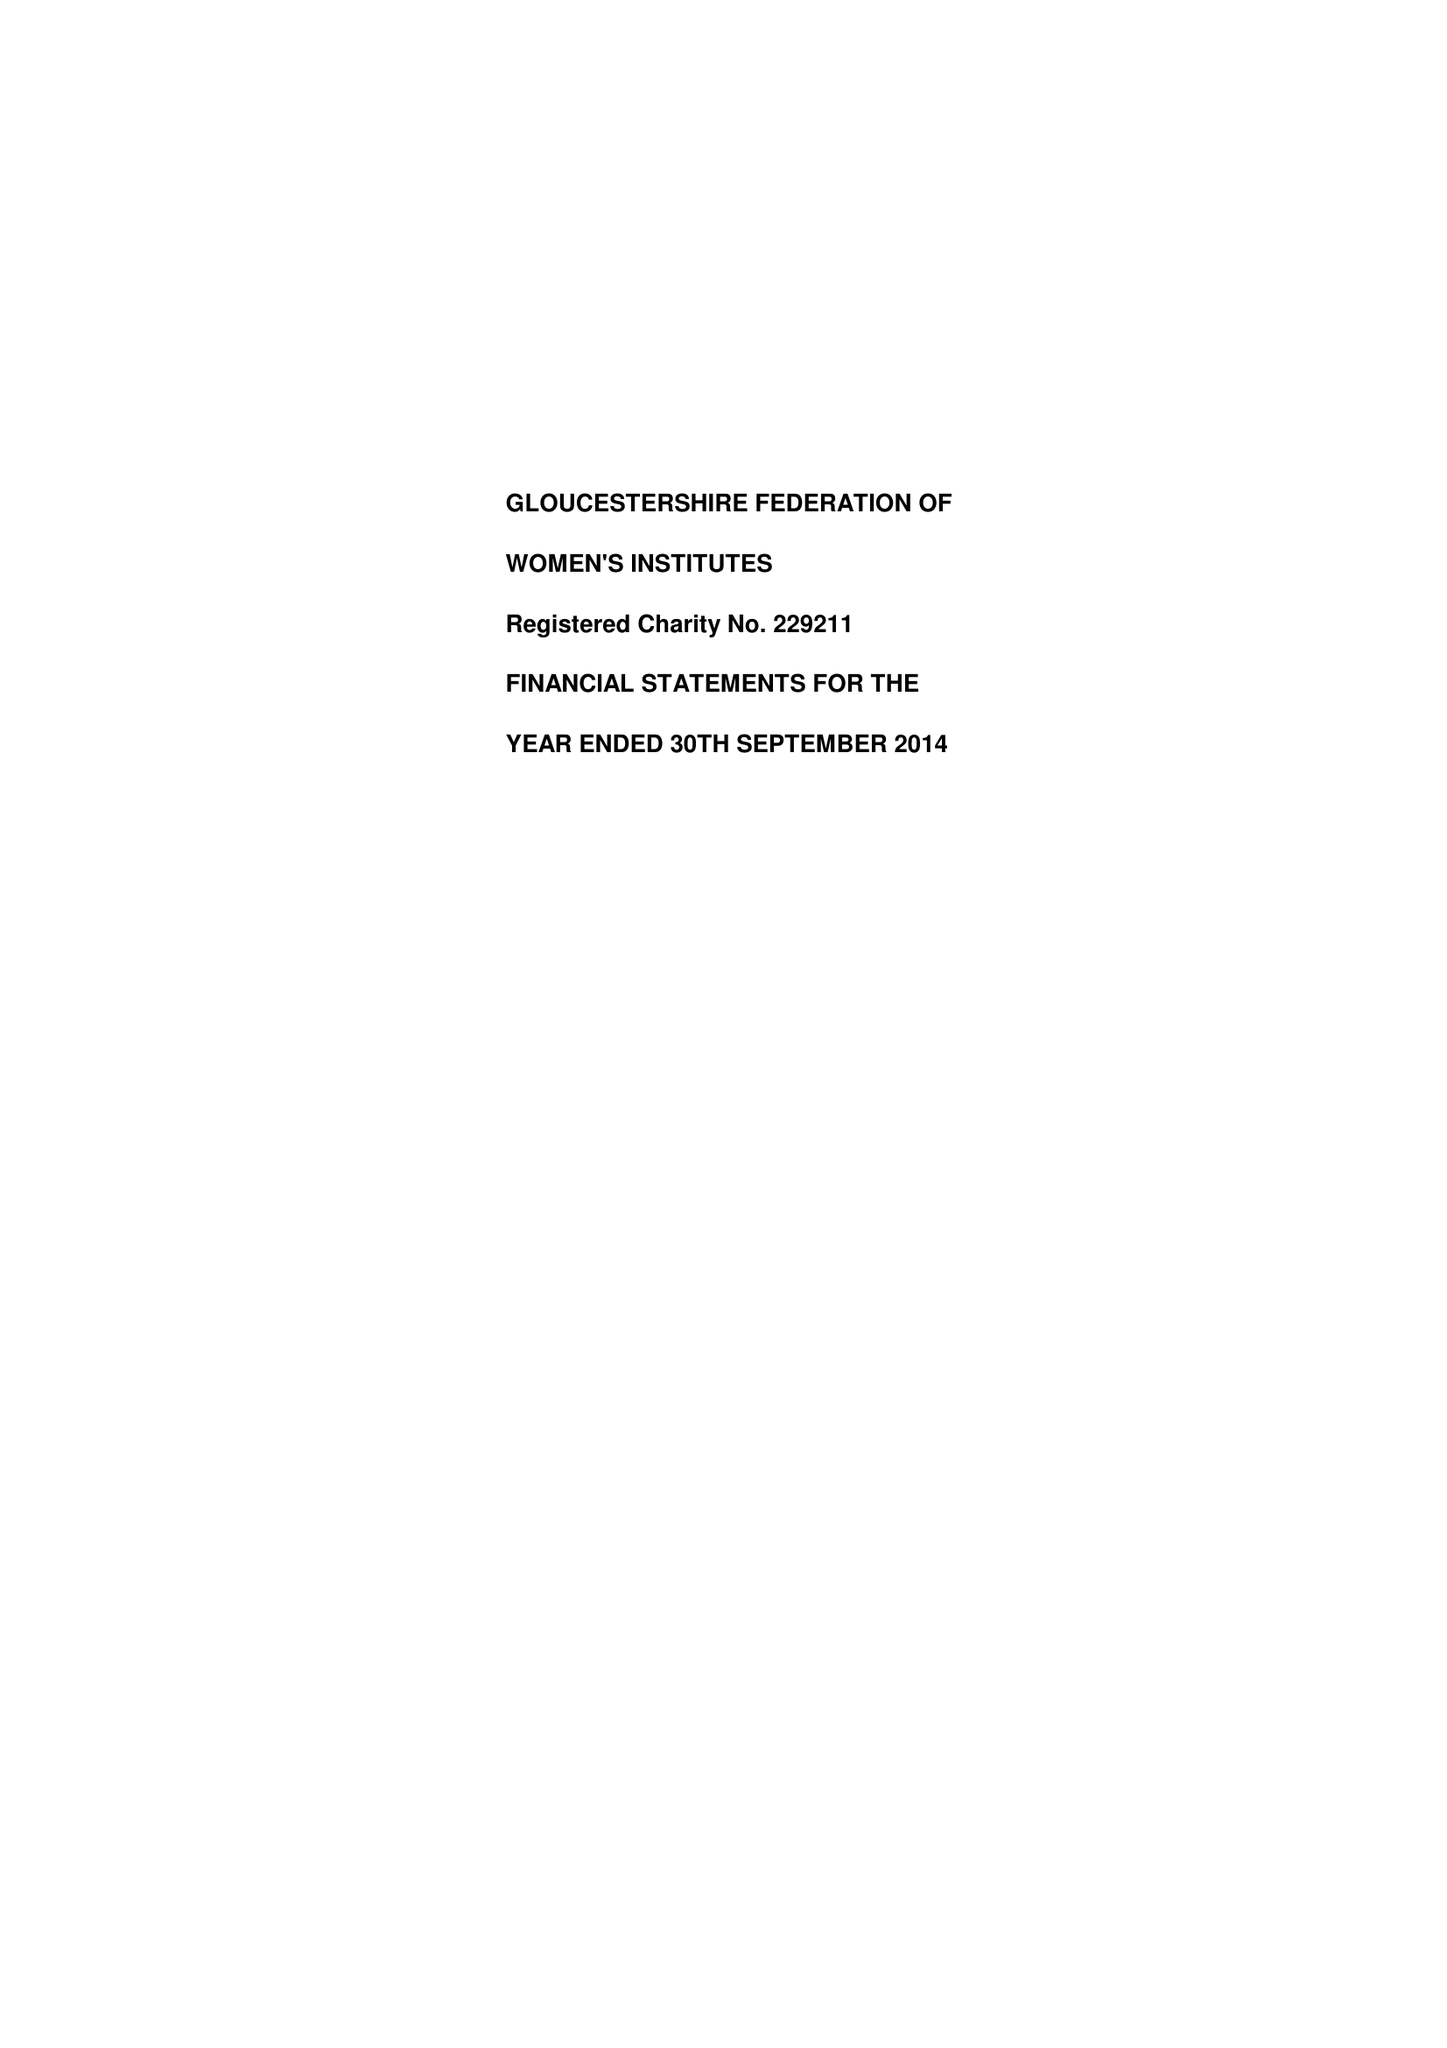What is the value for the charity_name?
Answer the question using a single word or phrase. Women's Institutes - Gloucestershire Federation 